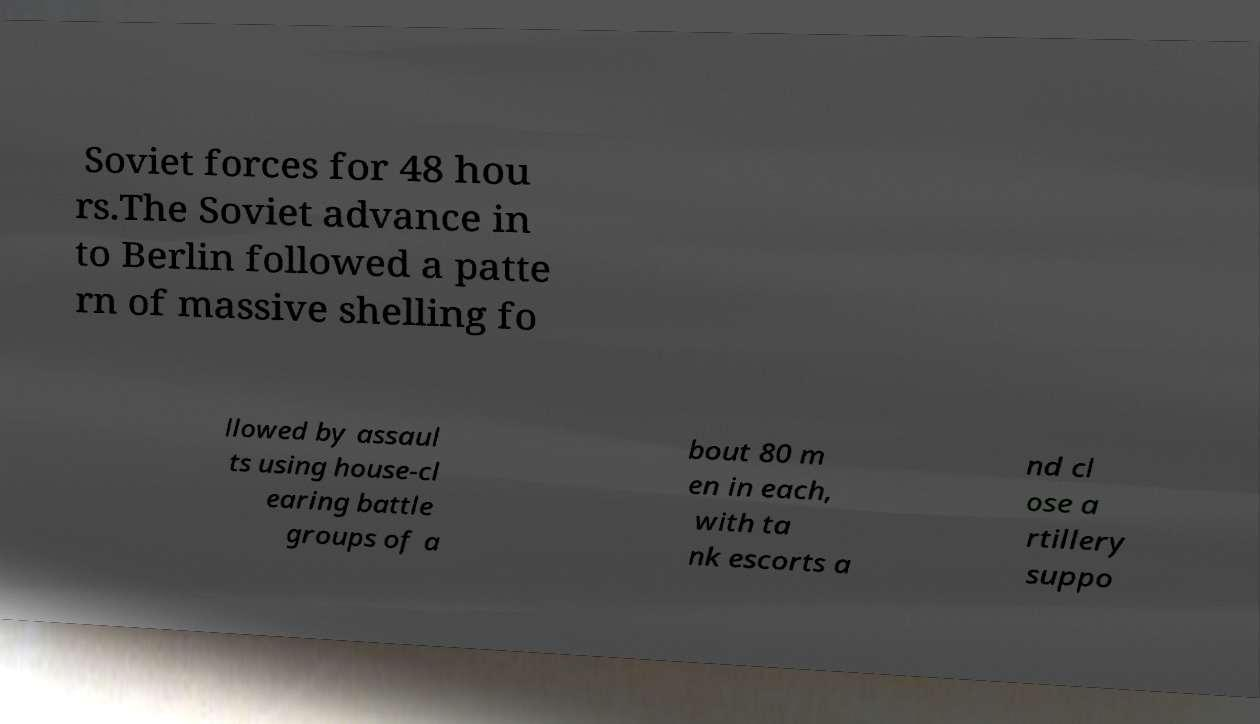Could you assist in decoding the text presented in this image and type it out clearly? Soviet forces for 48 hou rs.The Soviet advance in to Berlin followed a patte rn of massive shelling fo llowed by assaul ts using house-cl earing battle groups of a bout 80 m en in each, with ta nk escorts a nd cl ose a rtillery suppo 